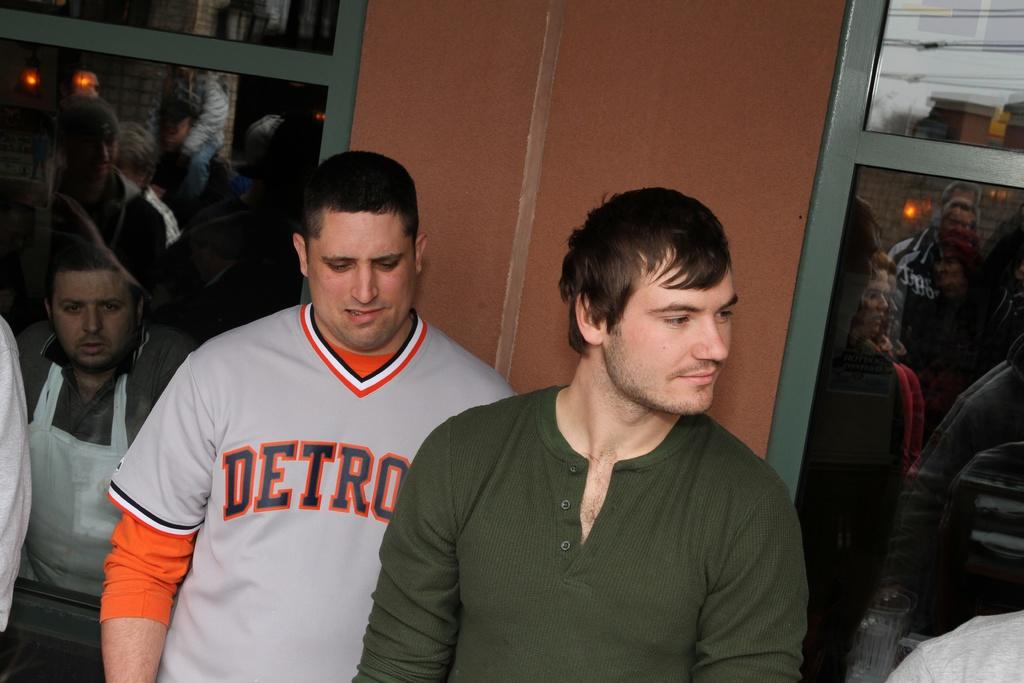What is the first letter of the word on the guy's shirt?
Your response must be concise. D. 